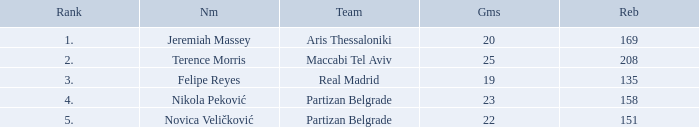How many Games for Terence Morris? 25.0. 